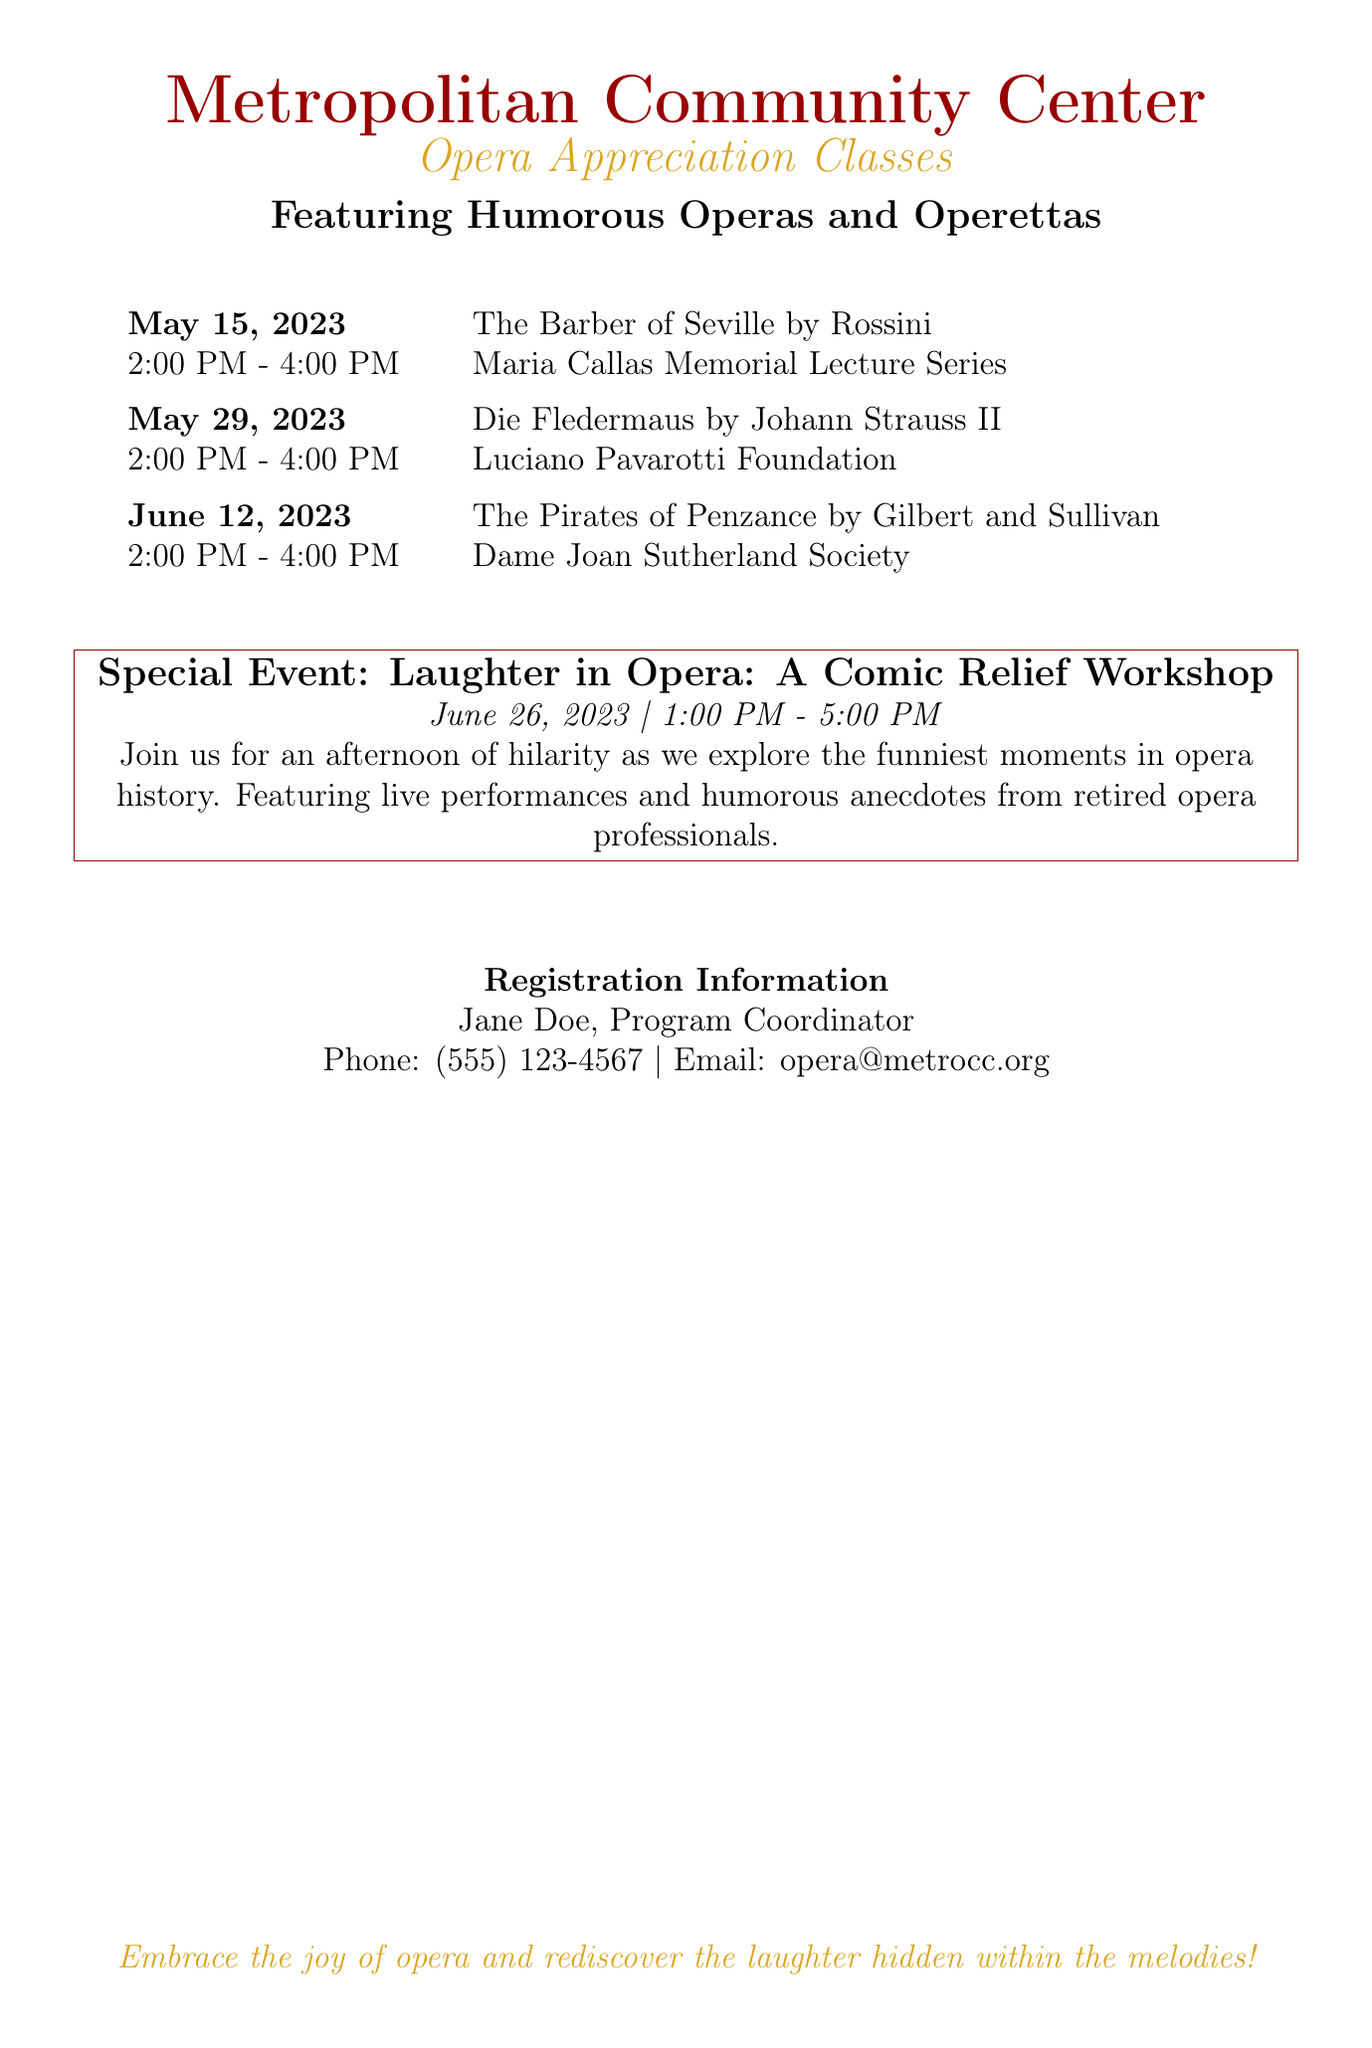What is the name of the first opera class? The first opera class is "The Barber of Seville" by Rossini.
Answer: The Barber of Seville What is the date of the special event? The special event is scheduled for June 26, 2023.
Answer: June 26, 2023 Who is the program coordinator? The program coordinator named in the document is Jane Doe.
Answer: Jane Doe What time do the opera classes start? All opera classes begin at 2:00 PM.
Answer: 2:00 PM How long does the comic relief workshop last? The comic relief workshop lasts for 4 hours, from 1:00 PM to 5:00 PM.
Answer: 4 hours What is the title of the third opera class? The title of the third opera class is "The Pirates of Penzance."
Answer: The Pirates of Penzance Which organization is associated with "Die Fledermaus"? The organization associated with "Die Fledermaus" is the Luciano Pavarotti Foundation.
Answer: Luciano Pavarotti Foundation What is the theme of the special event? The theme of the special event is "Laughter in Opera."
Answer: Laughter in Opera 